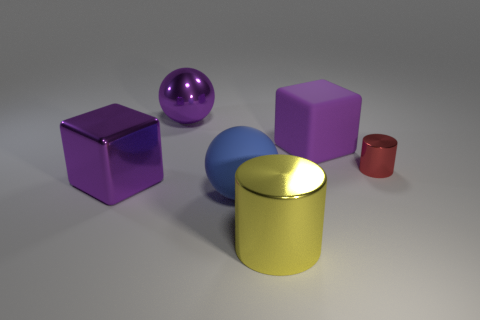What number of red objects are rubber spheres or tiny metallic cylinders?
Your answer should be compact. 1. The metallic ball has what color?
Your answer should be very brief. Purple. What size is the red cylinder that is the same material as the large purple ball?
Provide a succinct answer. Small. What number of purple matte objects have the same shape as the yellow thing?
Keep it short and to the point. 0. Are there any other things that are the same size as the yellow metal thing?
Ensure brevity in your answer.  Yes. What size is the red thing that is in front of the big purple object right of the large purple metal ball?
Give a very brief answer. Small. What material is the purple cube that is the same size as the purple matte thing?
Give a very brief answer. Metal. Are there any small red objects that have the same material as the blue sphere?
Provide a succinct answer. No. There is a metal cylinder behind the large matte thing that is in front of the purple object that is to the right of the yellow thing; what is its color?
Your response must be concise. Red. Is the color of the large ball that is behind the purple rubber block the same as the object left of the metallic ball?
Make the answer very short. Yes. 